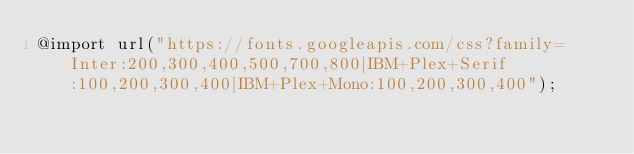Convert code to text. <code><loc_0><loc_0><loc_500><loc_500><_CSS_>@import url("https://fonts.googleapis.com/css?family=Inter:200,300,400,500,700,800|IBM+Plex+Serif:100,200,300,400|IBM+Plex+Mono:100,200,300,400");
</code> 